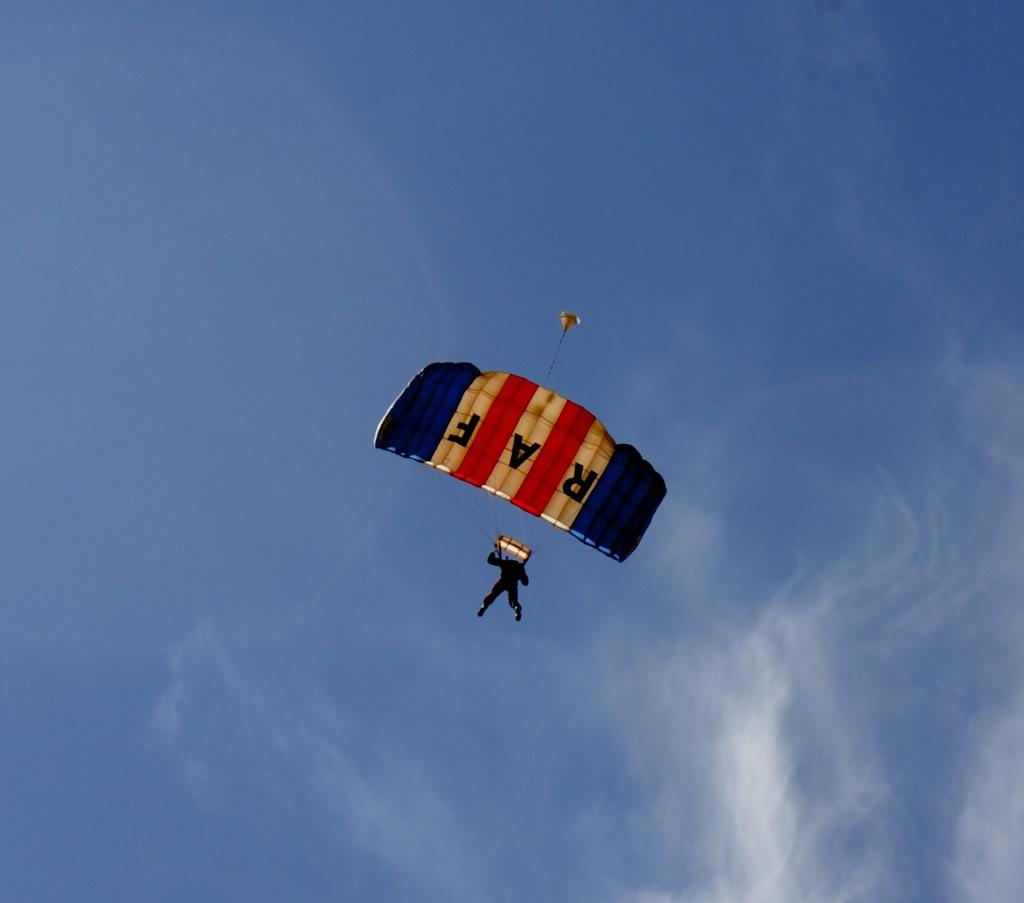Provide a one-sentence caption for the provided image. A man from the RAF is parachuting to the ground. 